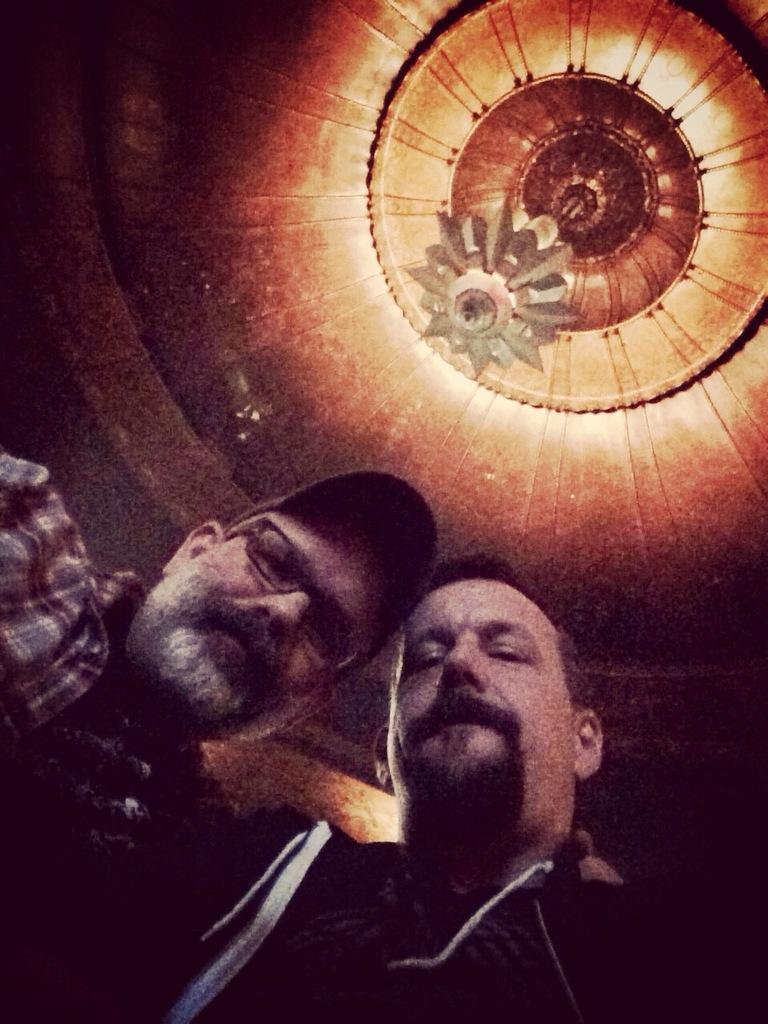How many people are present in the image? There are two people standing in the image. What can be seen hanging from the ceiling in the image? There is a chandelier hanging from the ceiling in the image. What type of muscle is visible in the image? There is no muscle visible in the image; it features two people standing and a chandelier hanging from the ceiling. 